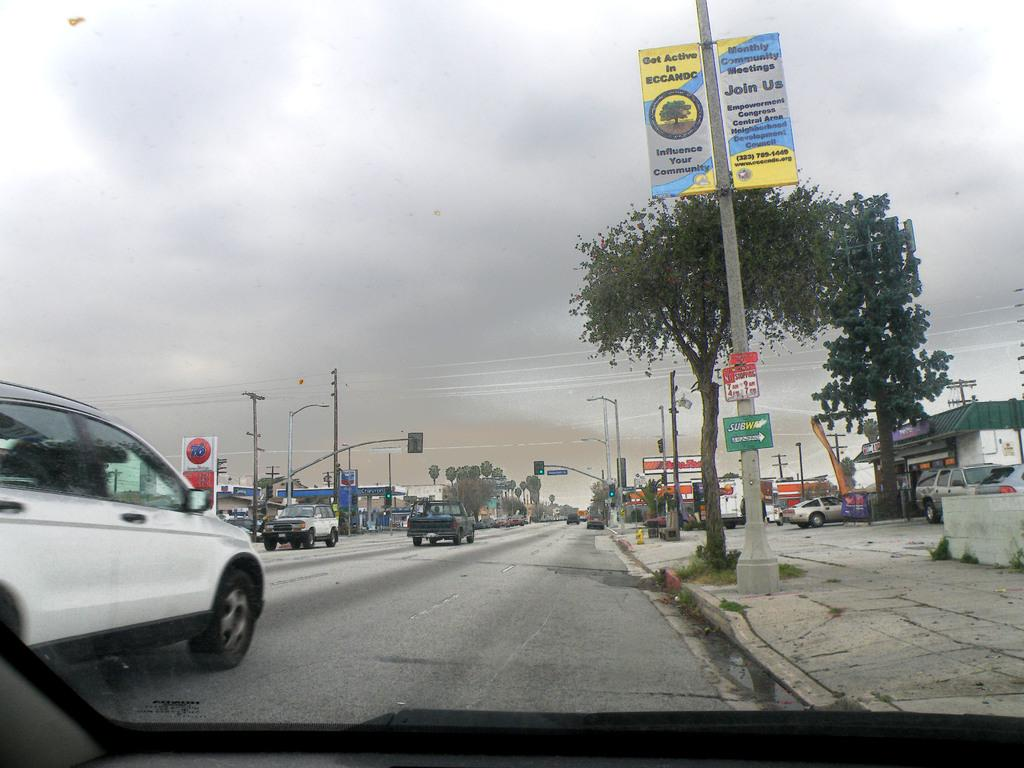What types of objects are on the ground in the image? There are vehicles on the ground in the image. What natural elements can be seen in the image? Trees are visible in the image. What traffic control devices are present in the image? Traffic signals are present in the image. What type of signage is visible in the image? Posters are visible in the image. What type of structures are present in the image? There are buildings in the image. What type of infrastructure is present in the image? Electric poles are present in the image. What type of utility lines are visible in the image? Wires are visible in the image. What is visible in the background of the image? The sky is visible in the background of the image. What type of substance is being controlled by the vehicles in the image? There is no indication in the image that any substance is being controlled by the vehicles. What type of van is visible in the image? There is no van present in the image. 